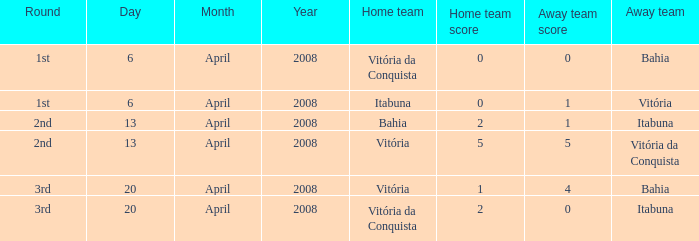What is the name of the home team with a round of 2nd and Vitória da Conquista as the way team? Vitória. 